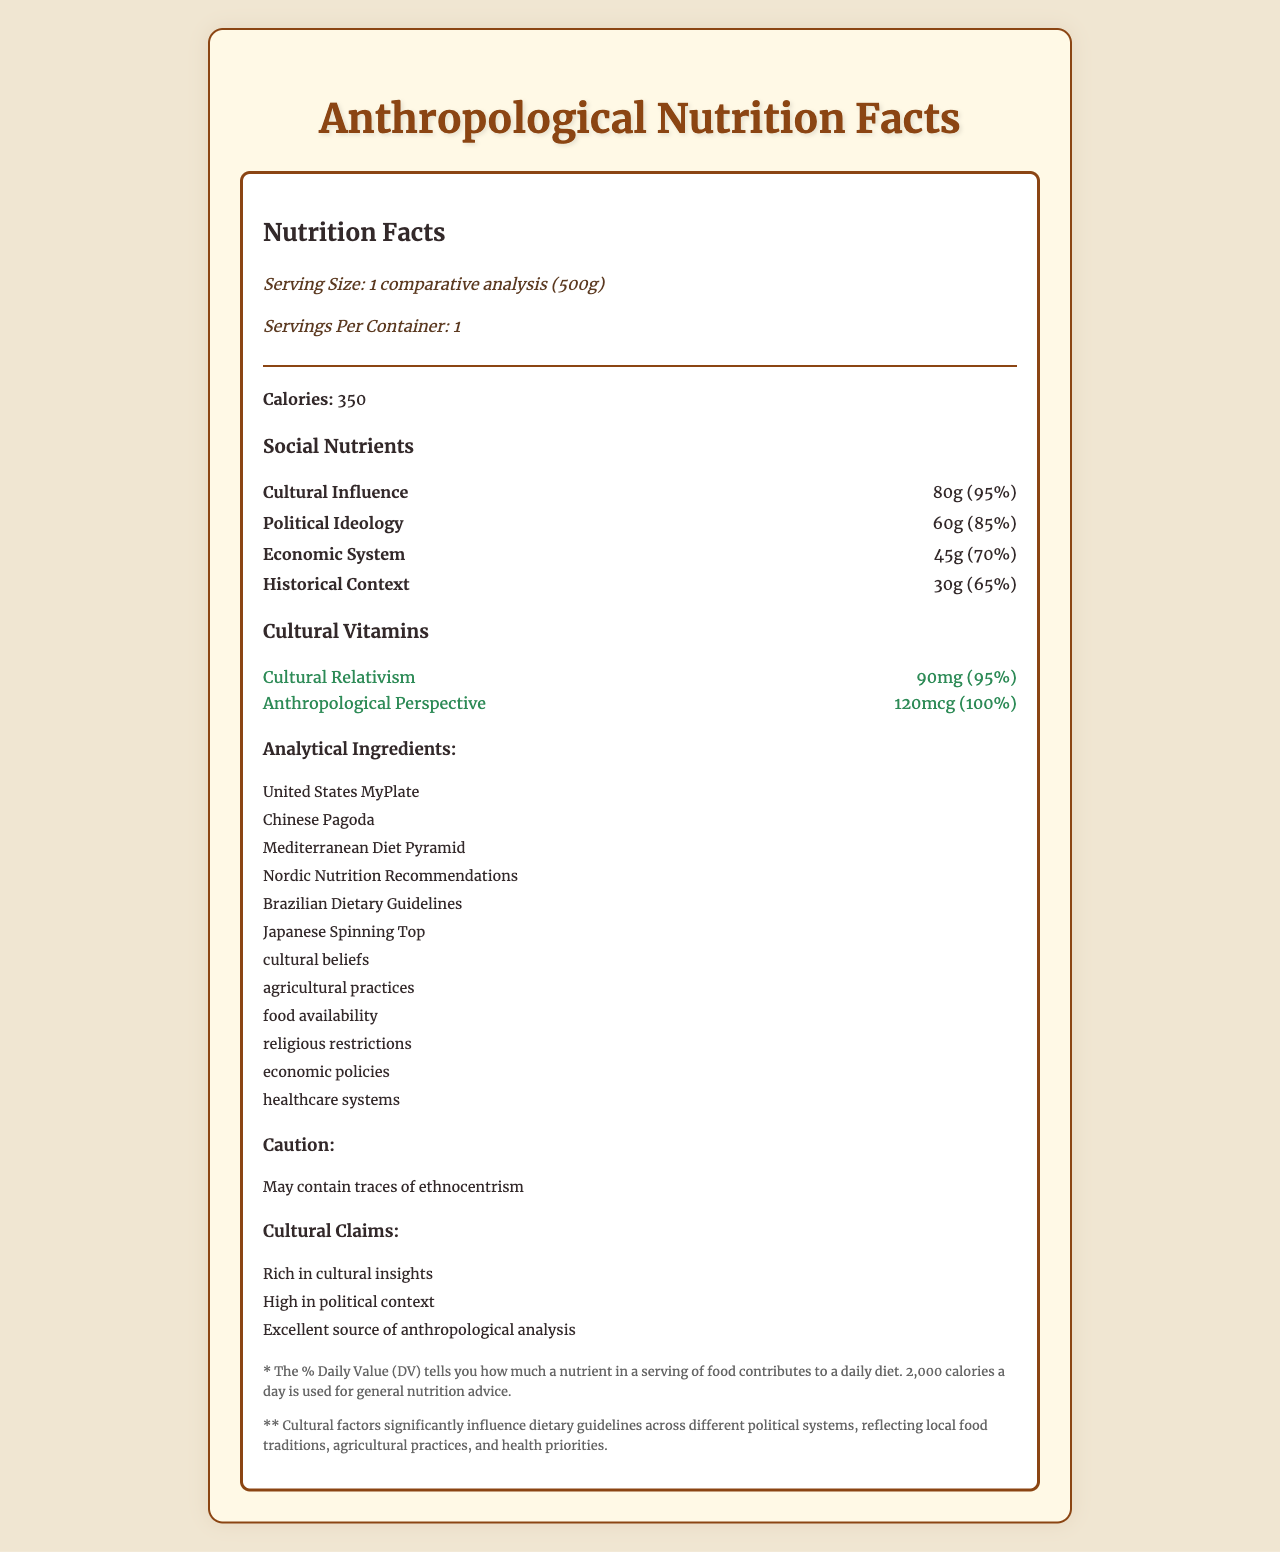what is the serving size? The serving size is explicitly mentioned at the beginning of the document under the "Nutrition Facts" section.
Answer: 1 comparative analysis (500g) how many servings per container are there? The document specifies that there is 1 serving per container.
Answer: 1 how many calories are in one serving? The document lists the calorie content as 350 per serving.
Answer: 350 which nutrient has the highest daily value percentage? According to the "Social Nutrients" section, Cultural Influence has a daily value percentage of 95%.
Answer: Cultural Influence list the types of "Cultural Vitamins" included. The document lists Cultural Relativism and Anthropological Perspective under the "Cultural Vitamins" section.
Answer: Cultural Relativism, Anthropological Perspective which dietary guideline is rich in cultural insights? A. United States MyPlate B. Chinese Pagoda C. Nordic Nutrition Recommendations D. Brazilian Dietary Guidelines The document lists "Rich in cultural insights" under the claims for Brazilian Dietary Guidelines.
Answer: D which analytical ingredient is not listed? A. Agricultural practices B. Healthcare systems C. Sociopolitical structures D. Food availability The document does not mention "Sociopolitical structures" among the analytical ingredients.
Answer: C are cultural factors considered significant in shaping dietary guidelines? The footnotes explicitly state that cultural factors significantly influence dietary guidelines across different political systems.
Answer: Yes does the nutritional label include any allergens? The document includes a caution that it "May contain traces of ethnocentrism."
Answer: Yes summarize the main idea of the document. The document focuses on illustrating how cultural influences are a significant driver in the formulation of dietary guidelines, highlighting specific nutrients, vitamins, and ingredients that represent different cultural and political factors.
Answer: The document provides a comparative analysis of dietary guidelines across different political systems, emphasizing the role of cultural factors in shaping these guidelines. It includes nutritional information such as serving size, calories, and specific social nutrients and cultural vitamins, along with claims and analytical ingredients reflective of various cultural and political contexts. how does the historical context compare in daily value percentage to the economic system? The document lists Historical Context with a daily value of 65% and Economic System with a daily value of 70%.
Answer: 65% vs. 70% how much anthropological perspective is included in the vitamins section? The document specifies that the amount of Anthropological Perspective provided is 120mcg.
Answer: 120mcg what is the caution mentioned in the document? The allergen section explicitly mentions this caution.
Answer: May contain traces of ethnocentrism what is the daily value percentage of cultural relativism? The document lists Cultural Relativism with a daily value percentage of 95%.
Answer: 95% which nutrient has the lowest amount in grams? The document lists Historical Context as having 30g, which is the lowest among the listed nutrients.
Answer: Historical Context which nutrient has a higher daily value percentage, political ideology or economic system? A. political ideology B. economic system Political Ideology has a daily value percentage of 85%, while Economic System has 70%.
Answer: A what percentage of the daily value does political ideology cover? The document specifies that Political Ideology covers 85% of the daily value.
Answer: 85% which cultural factor is not mentioned as an analytical ingredient? There's no mention of "Sociopolitical influences" among the listed analytical ingredients.
Answer: Sociopolitical influences does the data indicate how these nutrients vary over time? The document provides a snapshot of the current nutritional value but does not include information on how these values might change over time.
Answer: Cannot be determined 